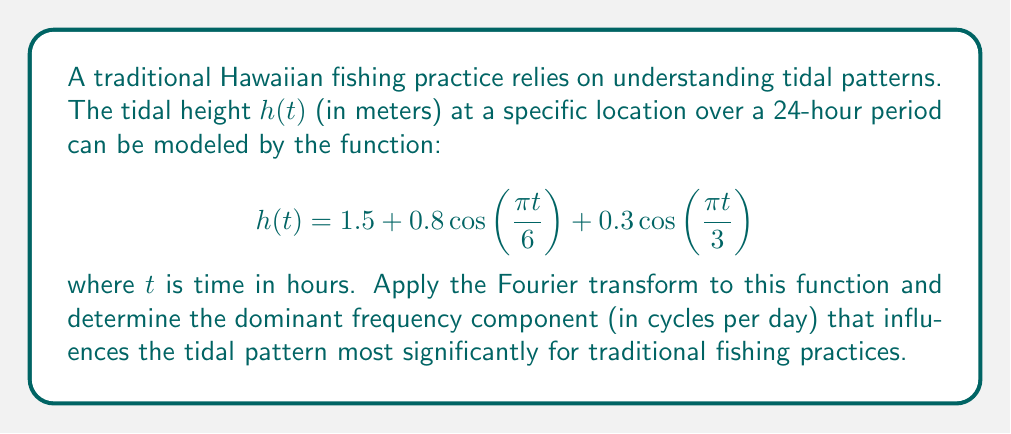Can you answer this question? To solve this problem, we'll follow these steps:

1) First, recall that the Fourier transform of a cosine function is given by:

   $$\mathcal{F}\{\cos(2\pi ft)\} = \frac{1}{2}[\delta(f-f_0) + \delta(f+f_0)]$$

   where $f_0$ is the frequency of the cosine function.

2) In our tidal function, we have two cosine terms:

   $$0.8\cos\left(\frac{\pi t}{6}\right) \text{ and } 0.3\cos\left(\frac{\pi t}{3}\right)$$

3) For the first term, $\frac{\pi t}{6} = 2\pi ft$, so $f = \frac{1}{12}$ cycles/hour = 2 cycles/day

4) For the second term, $\frac{\pi t}{3} = 2\pi ft$, so $f = \frac{1}{6}$ cycles/hour = 4 cycles/day

5) The constant term 1.5 will transform to a delta function at zero frequency.

6) Therefore, the Fourier transform of $h(t)$ is:

   $$H(f) = 1.5\delta(f) + 0.4[\delta(f-2) + \delta(f+2)] + 0.15[\delta(f-4) + \delta(f+4)]$$

   where $f$ is in cycles per day.

7) The amplitude of each component in the frequency domain is:
   - 1.5 at 0 cycles/day
   - 0.4 at ±2 cycles/day
   - 0.15 at ±4 cycles/day

8) The dominant frequency is the one with the largest amplitude (excluding the DC component at 0 cycles/day), which is 2 cycles/day with an amplitude of 0.4.
Answer: The dominant frequency component influencing the tidal pattern most significantly is 2 cycles per day. 